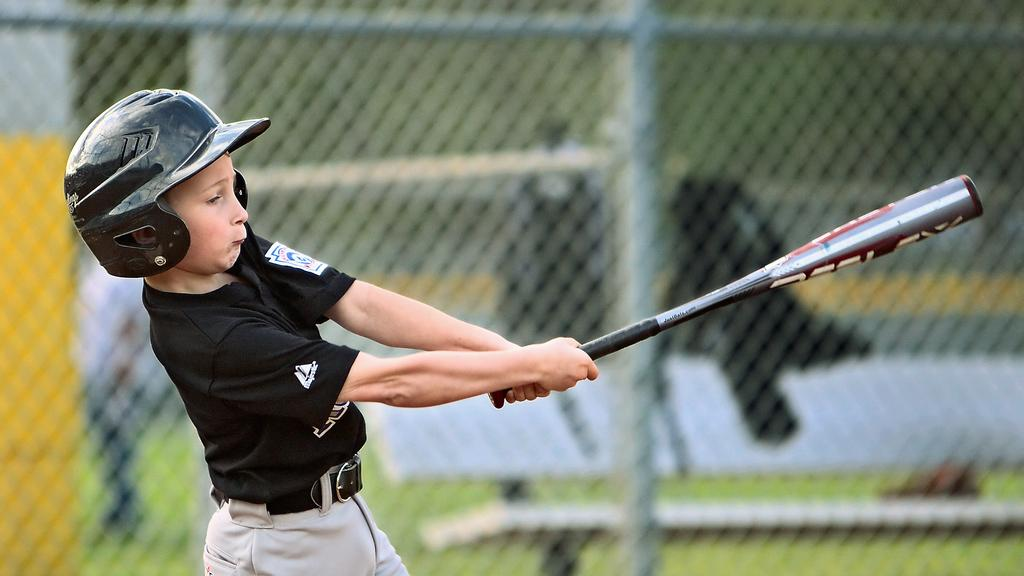What is the main subject of the image? There is a child in the image. What is the child doing in the image? The child is standing and holding a baseball bat. What can be seen in the background of the image? There is a net fence in the background, and the background is blurred. How many losses has the child experienced in the image? There is no indication of any losses in the image; it simply shows a child holding a baseball bat. Are there any giants visible in the image? There are no giants present in the image. 